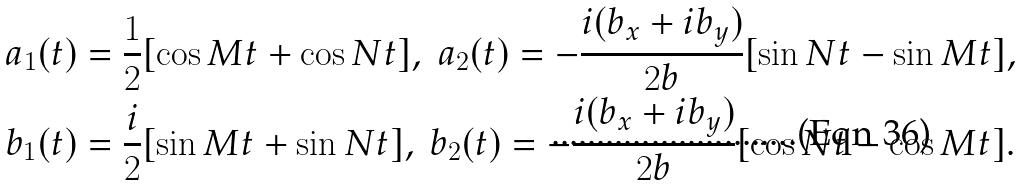Convert formula to latex. <formula><loc_0><loc_0><loc_500><loc_500>a _ { 1 } ( t ) & = \frac { 1 } { 2 } [ \cos M t + \cos N t ] , \text { } a _ { 2 } ( t ) = - \frac { i ( b _ { x } + i b _ { y } ) } { 2 b } [ \sin N t - \sin M t ] , \\ b _ { 1 } ( t ) & = \frac { i } { 2 } [ \sin M t + \sin N t ] , \text { } b _ { 2 } ( t ) = - \frac { i ( b _ { x } + i b _ { y } ) } { 2 b } [ \cos N t - \cos M t ] .</formula> 